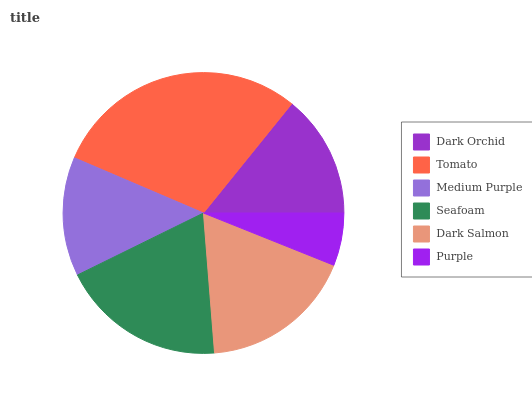Is Purple the minimum?
Answer yes or no. Yes. Is Tomato the maximum?
Answer yes or no. Yes. Is Medium Purple the minimum?
Answer yes or no. No. Is Medium Purple the maximum?
Answer yes or no. No. Is Tomato greater than Medium Purple?
Answer yes or no. Yes. Is Medium Purple less than Tomato?
Answer yes or no. Yes. Is Medium Purple greater than Tomato?
Answer yes or no. No. Is Tomato less than Medium Purple?
Answer yes or no. No. Is Dark Salmon the high median?
Answer yes or no. Yes. Is Dark Orchid the low median?
Answer yes or no. Yes. Is Seafoam the high median?
Answer yes or no. No. Is Dark Salmon the low median?
Answer yes or no. No. 